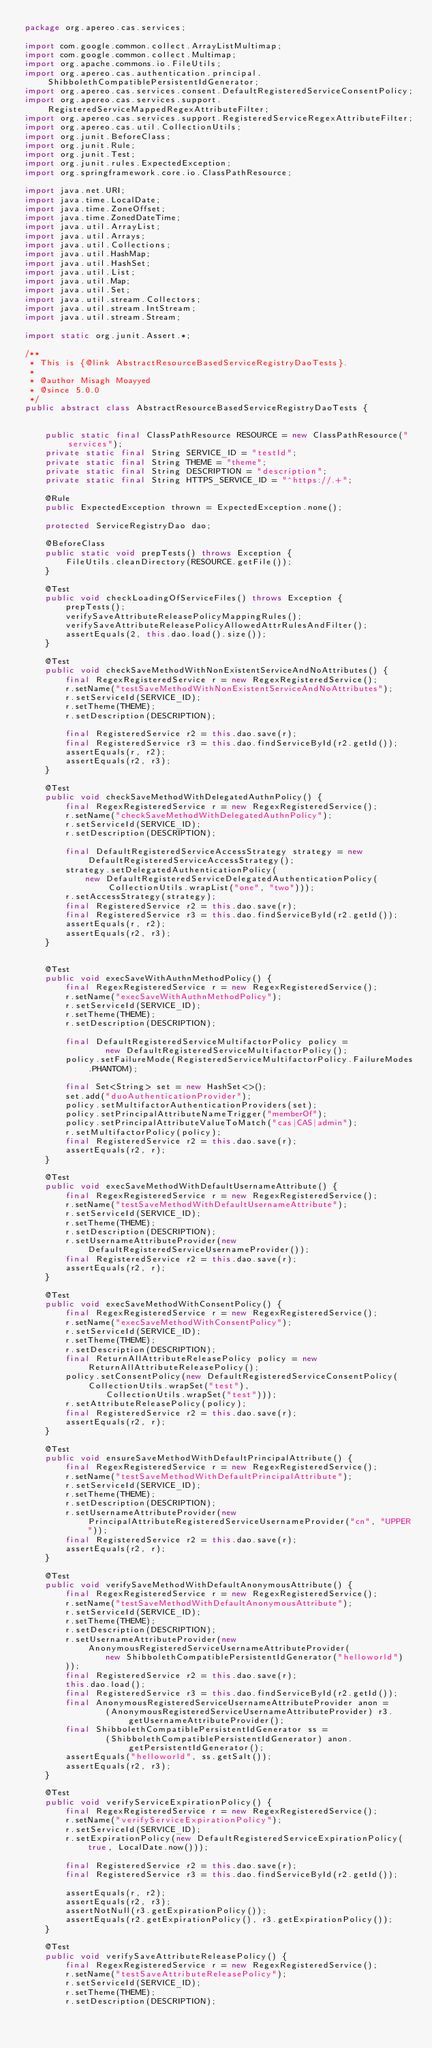Convert code to text. <code><loc_0><loc_0><loc_500><loc_500><_Java_>package org.apereo.cas.services;

import com.google.common.collect.ArrayListMultimap;
import com.google.common.collect.Multimap;
import org.apache.commons.io.FileUtils;
import org.apereo.cas.authentication.principal.ShibbolethCompatiblePersistentIdGenerator;
import org.apereo.cas.services.consent.DefaultRegisteredServiceConsentPolicy;
import org.apereo.cas.services.support.RegisteredServiceMappedRegexAttributeFilter;
import org.apereo.cas.services.support.RegisteredServiceRegexAttributeFilter;
import org.apereo.cas.util.CollectionUtils;
import org.junit.BeforeClass;
import org.junit.Rule;
import org.junit.Test;
import org.junit.rules.ExpectedException;
import org.springframework.core.io.ClassPathResource;

import java.net.URI;
import java.time.LocalDate;
import java.time.ZoneOffset;
import java.time.ZonedDateTime;
import java.util.ArrayList;
import java.util.Arrays;
import java.util.Collections;
import java.util.HashMap;
import java.util.HashSet;
import java.util.List;
import java.util.Map;
import java.util.Set;
import java.util.stream.Collectors;
import java.util.stream.IntStream;
import java.util.stream.Stream;

import static org.junit.Assert.*;

/**
 * This is {@link AbstractResourceBasedServiceRegistryDaoTests}.
 *
 * @author Misagh Moayyed
 * @since 5.0.0
 */
public abstract class AbstractResourceBasedServiceRegistryDaoTests {


    public static final ClassPathResource RESOURCE = new ClassPathResource("services");
    private static final String SERVICE_ID = "testId";
    private static final String THEME = "theme";
    private static final String DESCRIPTION = "description";
    private static final String HTTPS_SERVICE_ID = "^https://.+";

    @Rule
    public ExpectedException thrown = ExpectedException.none();

    protected ServiceRegistryDao dao;

    @BeforeClass
    public static void prepTests() throws Exception {
        FileUtils.cleanDirectory(RESOURCE.getFile());
    }

    @Test
    public void checkLoadingOfServiceFiles() throws Exception {
        prepTests();
        verifySaveAttributeReleasePolicyMappingRules();
        verifySaveAttributeReleasePolicyAllowedAttrRulesAndFilter();
        assertEquals(2, this.dao.load().size());
    }

    @Test
    public void checkSaveMethodWithNonExistentServiceAndNoAttributes() {
        final RegexRegisteredService r = new RegexRegisteredService();
        r.setName("testSaveMethodWithNonExistentServiceAndNoAttributes");
        r.setServiceId(SERVICE_ID);
        r.setTheme(THEME);
        r.setDescription(DESCRIPTION);

        final RegisteredService r2 = this.dao.save(r);
        final RegisteredService r3 = this.dao.findServiceById(r2.getId());
        assertEquals(r, r2);
        assertEquals(r2, r3);
    }

    @Test
    public void checkSaveMethodWithDelegatedAuthnPolicy() {
        final RegexRegisteredService r = new RegexRegisteredService();
        r.setName("checkSaveMethodWithDelegatedAuthnPolicy");
        r.setServiceId(SERVICE_ID);
        r.setDescription(DESCRIPTION);

        final DefaultRegisteredServiceAccessStrategy strategy = new DefaultRegisteredServiceAccessStrategy();
        strategy.setDelegatedAuthenticationPolicy(
            new DefaultRegisteredServiceDelegatedAuthenticationPolicy(CollectionUtils.wrapList("one", "two")));
        r.setAccessStrategy(strategy);
        final RegisteredService r2 = this.dao.save(r);
        final RegisteredService r3 = this.dao.findServiceById(r2.getId());
        assertEquals(r, r2);
        assertEquals(r2, r3);
    }

    
    @Test
    public void execSaveWithAuthnMethodPolicy() {
        final RegexRegisteredService r = new RegexRegisteredService();
        r.setName("execSaveWithAuthnMethodPolicy");
        r.setServiceId(SERVICE_ID);
        r.setTheme(THEME);
        r.setDescription(DESCRIPTION);

        final DefaultRegisteredServiceMultifactorPolicy policy =
                new DefaultRegisteredServiceMultifactorPolicy();
        policy.setFailureMode(RegisteredServiceMultifactorPolicy.FailureModes.PHANTOM);

        final Set<String> set = new HashSet<>();
        set.add("duoAuthenticationProvider");
        policy.setMultifactorAuthenticationProviders(set);
        policy.setPrincipalAttributeNameTrigger("memberOf");
        policy.setPrincipalAttributeValueToMatch("cas|CAS|admin");
        r.setMultifactorPolicy(policy);
        final RegisteredService r2 = this.dao.save(r);
        assertEquals(r2, r);
    }

    @Test
    public void execSaveMethodWithDefaultUsernameAttribute() {
        final RegexRegisteredService r = new RegexRegisteredService();
        r.setName("testSaveMethodWithDefaultUsernameAttribute");
        r.setServiceId(SERVICE_ID);
        r.setTheme(THEME);
        r.setDescription(DESCRIPTION);
        r.setUsernameAttributeProvider(new DefaultRegisteredServiceUsernameProvider());
        final RegisteredService r2 = this.dao.save(r);
        assertEquals(r2, r);
    }

    @Test
    public void execSaveMethodWithConsentPolicy() {
        final RegexRegisteredService r = new RegexRegisteredService();
        r.setName("execSaveMethodWithConsentPolicy");
        r.setServiceId(SERVICE_ID);
        r.setTheme(THEME);
        r.setDescription(DESCRIPTION);
        final ReturnAllAttributeReleasePolicy policy = new ReturnAllAttributeReleasePolicy();
        policy.setConsentPolicy(new DefaultRegisteredServiceConsentPolicy(CollectionUtils.wrapSet("test"),
                CollectionUtils.wrapSet("test")));
        r.setAttributeReleasePolicy(policy);
        final RegisteredService r2 = this.dao.save(r);
        assertEquals(r2, r);
    }

    @Test
    public void ensureSaveMethodWithDefaultPrincipalAttribute() {
        final RegexRegisteredService r = new RegexRegisteredService();
        r.setName("testSaveMethodWithDefaultPrincipalAttribute");
        r.setServiceId(SERVICE_ID);
        r.setTheme(THEME);
        r.setDescription(DESCRIPTION);
        r.setUsernameAttributeProvider(new PrincipalAttributeRegisteredServiceUsernameProvider("cn", "UPPER"));
        final RegisteredService r2 = this.dao.save(r);
        assertEquals(r2, r);
    }

    @Test
    public void verifySaveMethodWithDefaultAnonymousAttribute() {
        final RegexRegisteredService r = new RegexRegisteredService();
        r.setName("testSaveMethodWithDefaultAnonymousAttribute");
        r.setServiceId(SERVICE_ID);
        r.setTheme(THEME);
        r.setDescription(DESCRIPTION);
        r.setUsernameAttributeProvider(new AnonymousRegisteredServiceUsernameAttributeProvider(
                new ShibbolethCompatiblePersistentIdGenerator("helloworld")
        ));
        final RegisteredService r2 = this.dao.save(r);
        this.dao.load();
        final RegisteredService r3 = this.dao.findServiceById(r2.getId());
        final AnonymousRegisteredServiceUsernameAttributeProvider anon =
                (AnonymousRegisteredServiceUsernameAttributeProvider) r3.getUsernameAttributeProvider();
        final ShibbolethCompatiblePersistentIdGenerator ss =
                (ShibbolethCompatiblePersistentIdGenerator) anon.getPersistentIdGenerator();
        assertEquals("helloworld", ss.getSalt());
        assertEquals(r2, r3);
    }

    @Test
    public void verifyServiceExpirationPolicy() {
        final RegexRegisteredService r = new RegexRegisteredService();
        r.setName("verifyServiceExpirationPolicy");
        r.setServiceId(SERVICE_ID);
        r.setExpirationPolicy(new DefaultRegisteredServiceExpirationPolicy(true, LocalDate.now()));

        final RegisteredService r2 = this.dao.save(r);
        final RegisteredService r3 = this.dao.findServiceById(r2.getId());

        assertEquals(r, r2);
        assertEquals(r2, r3);
        assertNotNull(r3.getExpirationPolicy());
        assertEquals(r2.getExpirationPolicy(), r3.getExpirationPolicy());
    }
    
    @Test
    public void verifySaveAttributeReleasePolicy() {
        final RegexRegisteredService r = new RegexRegisteredService();
        r.setName("testSaveAttributeReleasePolicy");
        r.setServiceId(SERVICE_ID);
        r.setTheme(THEME);
        r.setDescription(DESCRIPTION);</code> 